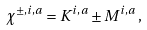Convert formula to latex. <formula><loc_0><loc_0><loc_500><loc_500>\chi ^ { \pm , i , a } = K ^ { i , a } \pm M ^ { i , a } \, ,</formula> 